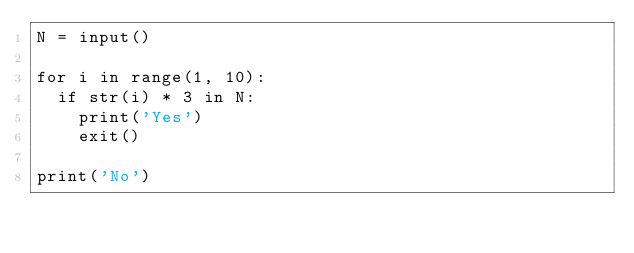<code> <loc_0><loc_0><loc_500><loc_500><_Python_>N = input()

for i in range(1, 10):
  if str(i) * 3 in N:
    print('Yes')
    exit()

print('No')</code> 